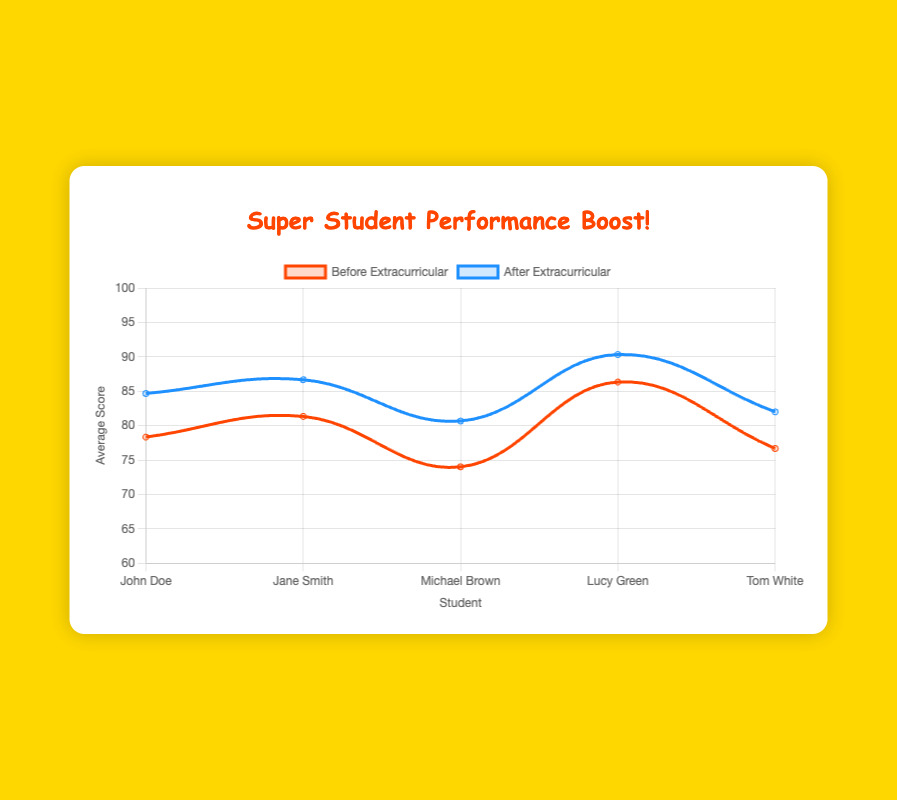Which student saw the most significant improvement in their average score? To determine the most significant improvement, we need to calculate the score difference for each student by subtracting their pre-activity score from their post-activity score. John: (85+88+81)/3 - (78+82+75)/3 = 84.67 - 78.33 = 6.34; Jane: (89+86+85)/3 - (84+79+81)/3 = 86.67 - 81.33 = 5.34; Michael: (80+83+79)/3 - (72+76+74)/3 = 80.67 - 74 = 6.67; Lucy: (90+92+89)/3 - (85+88+86)/3 = 90.33 - 86.33 = 4; Tom: (75+88+83)/3 - (70+82+78)/3 = 82 - 76.67 = 5.33. The student with the highest improvement is Michael with an improvement of 6.67.
Answer: Michael Brown Who had the highest average score before participating in extracurricular activities? Compare the pre-activity average scores for all students: John: 78.33, Jane: 81.33, Michael: 74, Lucy: 86.33, Tom: 76.67. Therefore, the highest pre-activity score belongs to Lucy.
Answer: Lucy Green Did all students improve their average scores after participating in extracurricular activities? Check the average pre- and post-activity scores for each student: John: 78.33 to 84.67, Jane: 81.33 to 86.67, Michael: 74 to 80.67, Lucy: 86.33 to 90.33, Tom: 76.67 to 82. All students have higher average scores post-activity.
Answer: Yes Which student showed the least improvement in their average score? Calculate the score difference for each student and find the minimum: John: 6.34, Jane: 5.34, Michael: 6.67, Lucy: 4, Tom: 5.33. The student with the least improvement is Lucy with an improvement of 4.
Answer: Lucy Green What was the average pre-activity score across all students? Sum all pre-activity scores and divide by the total number of scores: (78+82+75+84+79+81+72+76+74+85+88+86+70+82+78) / 15 = 1204 / 15 = 80.27
Answer: 80.27 Compare John's and Tom's post-activity scores. Who performed better on average? Calculate the post-activity average for John: (85+88+81)/3 = 84.67; Tom: (75+88+83)/3 = 82. Comparing these values, John performed better.
Answer: John Doe Which subject saw the highest improvement in average score for all students combined? Calculate the average improvement for each subject: Math ((85+89+75)-(78+84+70))/3 = (249-232)/3 = 5.67; Science ((88+86+83+92)-(82+79+76+88))/4 = (349-325)/4 = 6; English ((81+83)-(75+74))/2 = (164-149)/2 = 7.5; History (85-81)/1 = 4; Art (89-86)/1 = 3; Music (88-82)/1 = 6. Music had the highest subject improvement of 7.5 in average scores.
Answer: English 